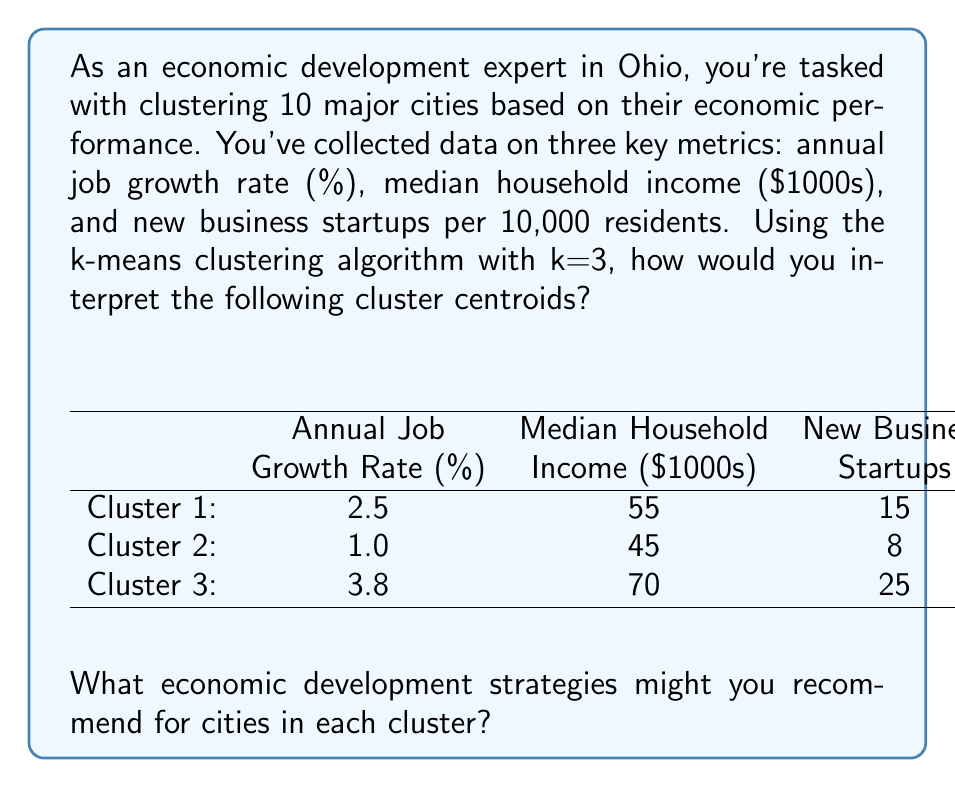What is the answer to this math problem? To interpret these cluster centroids and recommend strategies, let's break down the process:

1. Understanding the centroids:
   Each centroid represents the average values of the three metrics for cities in that cluster.
   
   Cluster 1: (2.5% job growth, $55,000 median income, 15 startups per 10,000 residents)
   Cluster 2: (1.0% job growth, $45,000 median income, 8 startups per 10,000 residents)
   Cluster 3: (3.8% job growth, $70,000 median income, 25 startups per 10,000 residents)

2. Interpreting the clusters:

   Cluster 1: Moderate performance
   - Average job growth
   - Moderate median income
   - Moderate startup activity

   Cluster 2: Underperforming
   - Low job growth
   - Lower median income
   - Lower startup activity

   Cluster 3: High performance
   - High job growth
   - High median income
   - High startup activity

3. Recommending strategies:

   For Cluster 1 (Moderate performance):
   - Focus on targeted industry growth to boost job creation
   - Implement workforce development programs to increase median income
   - Enhance entrepreneurship support to increase startup activity

   For Cluster 2 (Underperforming):
   - Prioritize job creation through business attraction and retention programs
   - Invest in skills training and education to improve workforce competitiveness
   - Develop incubator programs and provide more resources for startups

   For Cluster 3 (High performance):
   - Sustain growth by investing in infrastructure and quality of life improvements
   - Focus on talent attraction and retention to maintain high-skill workforce
   - Expand venture capital networks to support scaling of successful startups

These strategies are tailored to address the specific economic conditions represented by each cluster, aiming to improve or maintain performance across all three metrics.
Answer: Interpretation of clusters:
1. Moderate performance
2. Underperforming
3. High performance

Recommended strategies:
Cluster 1: Target industry growth, workforce development, enhance entrepreneurship support
Cluster 2: Prioritize job creation, invest in skills training, develop incubator programs
Cluster 3: Invest in infrastructure, focus on talent attraction/retention, expand venture capital networks 